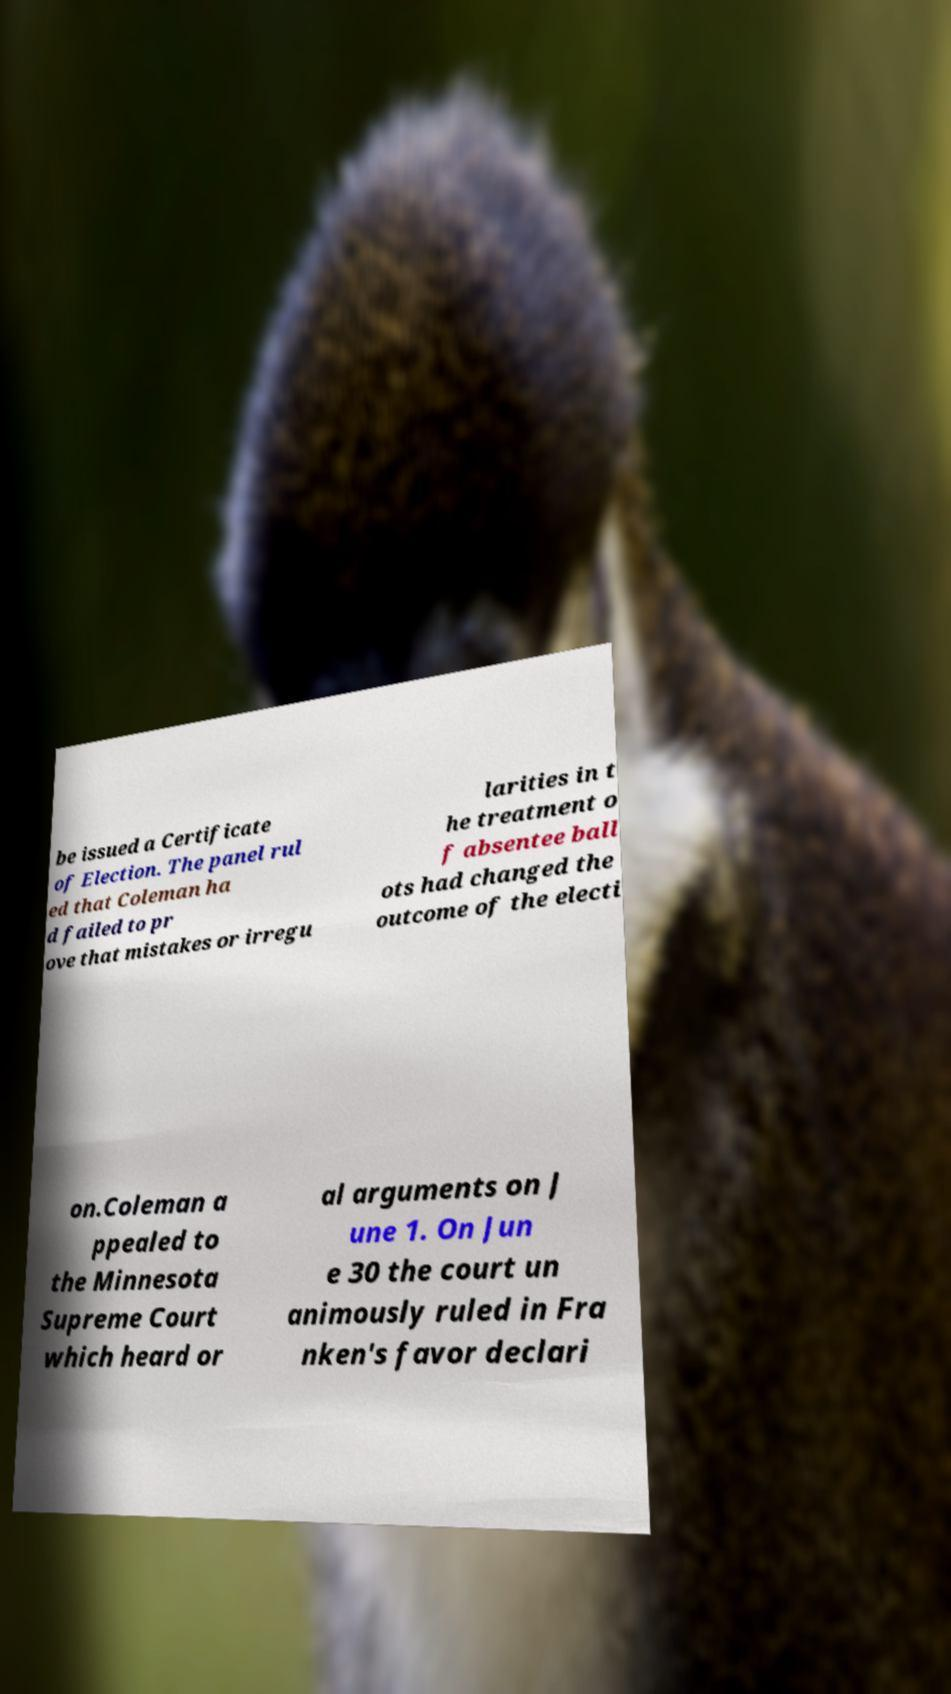There's text embedded in this image that I need extracted. Can you transcribe it verbatim? be issued a Certificate of Election. The panel rul ed that Coleman ha d failed to pr ove that mistakes or irregu larities in t he treatment o f absentee ball ots had changed the outcome of the electi on.Coleman a ppealed to the Minnesota Supreme Court which heard or al arguments on J une 1. On Jun e 30 the court un animously ruled in Fra nken's favor declari 